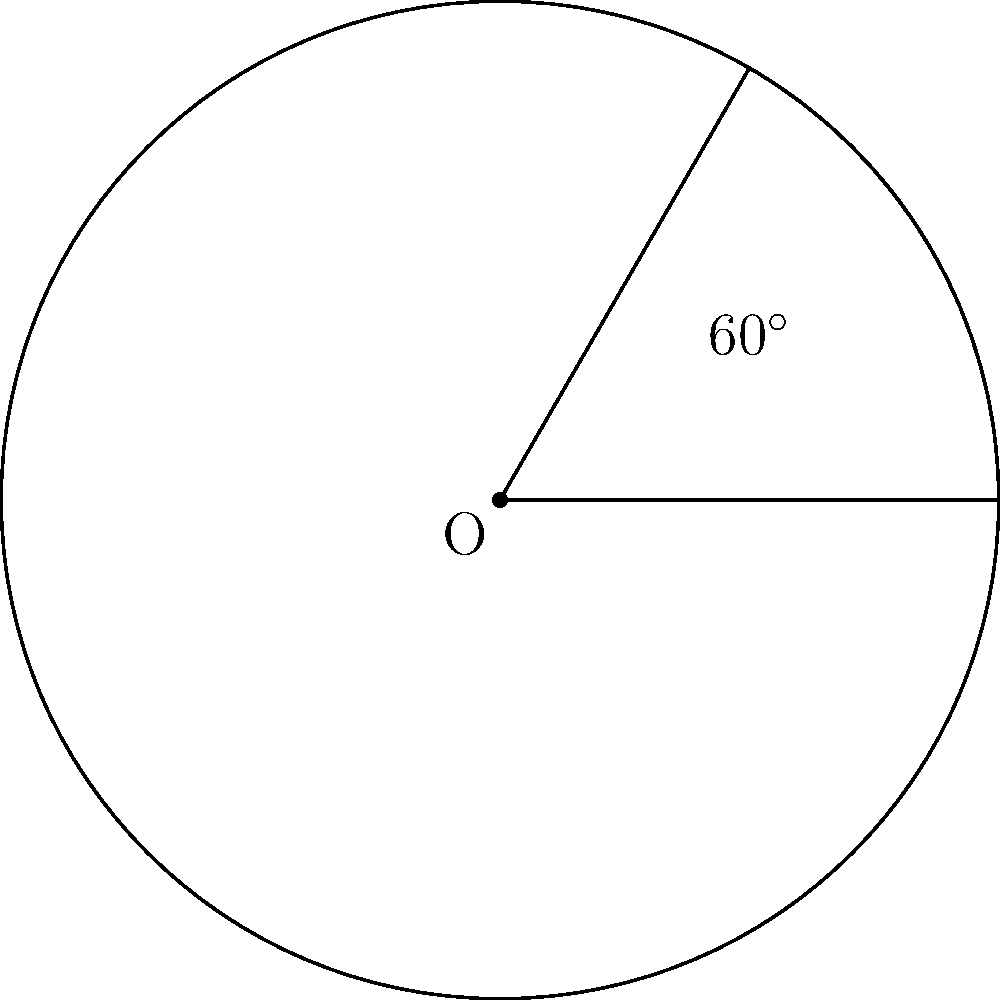You're planning a pizza party for 6 friends. To ensure everyone gets an equal share, you need to determine the central angle for each slice of the circular pizza. What should be the central angle (in degrees) for each slice? Let's approach this step-by-step:

1. Recall that a full circle contains 360°.

2. We need to divide the pizza equally among 6 friends, plus yourself. So, the total number of slices needed is 7.

3. To find the central angle for each slice, we need to divide the total degrees in a circle by the number of slices:

   $$\text{Central Angle} = \frac{\text{Total degrees in a circle}}{\text{Number of slices}}$$

4. Substituting the values:

   $$\text{Central Angle} = \frac{360°}{7}$$

5. Calculating:

   $$\text{Central Angle} = 51.43°$$

6. Since we're dealing with pizza slices, it's practical to round to the nearest whole degree:

   $$\text{Central Angle} ≈ 51°$$

Therefore, each slice of the pizza should have a central angle of approximately 51°.
Answer: 51° 